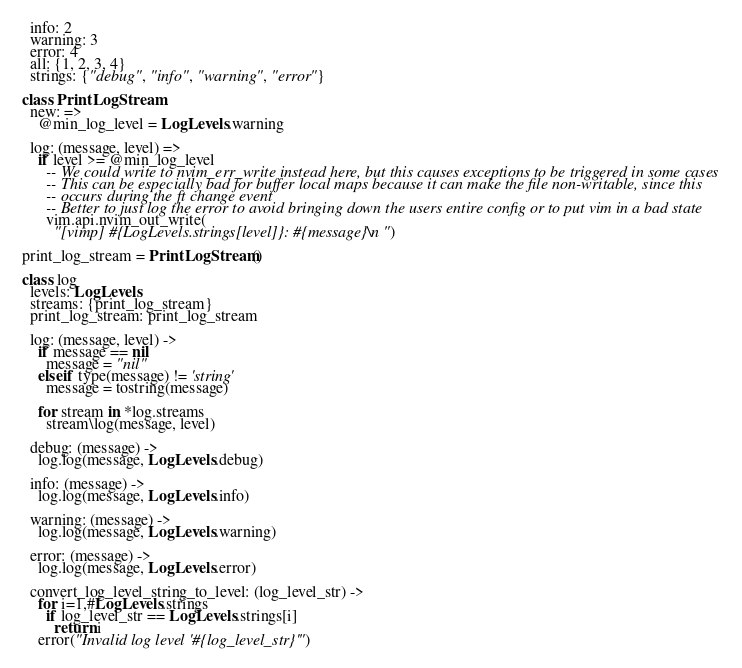<code> <loc_0><loc_0><loc_500><loc_500><_MoonScript_>  info: 2
  warning: 3
  error: 4
  all: {1, 2, 3, 4}
  strings: {"debug", "info", "warning", "error"}

class PrintLogStream
  new: =>
    @min_log_level = LogLevels.warning

  log: (message, level) =>
    if level >= @min_log_level
      -- We could write to nvim_err_write instead here, but this causes exceptions to be triggered in some cases
      -- This can be especially bad for buffer local maps because it can make the file non-writable, since this
      -- occurs during the ft change event
      -- Better to just log the error to avoid bringing down the users entire config or to put vim in a bad state
      vim.api.nvim_out_write(
        "[vimp] #{LogLevels.strings[level]}: #{message}\n")

print_log_stream = PrintLogStream()

class log
  levels: LogLevels
  streams: {print_log_stream}
  print_log_stream: print_log_stream

  log: (message, level) ->
    if message == nil
      message = "nil"
    elseif type(message) != 'string'
      message = tostring(message)

    for stream in *log.streams
      stream\log(message, level)

  debug: (message) ->
    log.log(message, LogLevels.debug)

  info: (message) ->
    log.log(message, LogLevels.info)

  warning: (message) ->
    log.log(message, LogLevels.warning)

  error: (message) ->
    log.log(message, LogLevels.error)

  convert_log_level_string_to_level: (log_level_str) ->
    for i=1,#LogLevels.strings
      if log_level_str == LogLevels.strings[i]
        return i
    error("Invalid log level '#{log_level_str}'")

</code> 